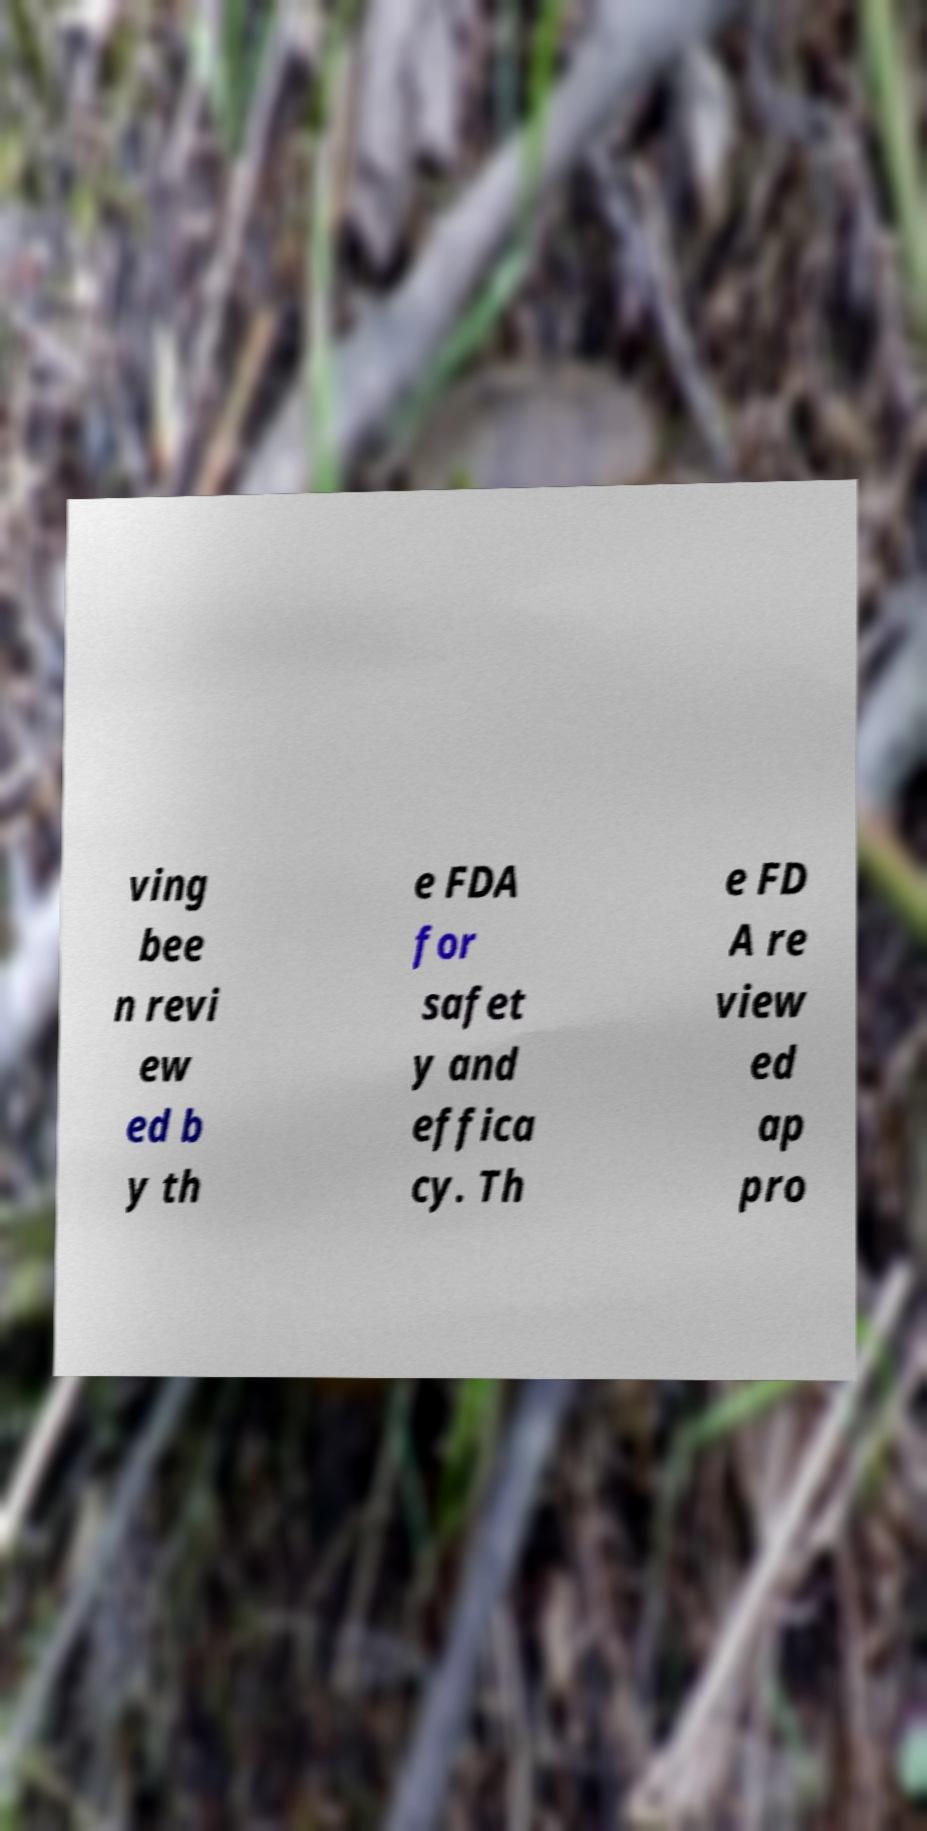Can you read and provide the text displayed in the image?This photo seems to have some interesting text. Can you extract and type it out for me? ving bee n revi ew ed b y th e FDA for safet y and effica cy. Th e FD A re view ed ap pro 